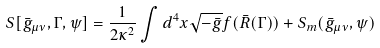Convert formula to latex. <formula><loc_0><loc_0><loc_500><loc_500>S [ \bar { g } _ { \mu \nu } , \Gamma , \psi ] = \frac { 1 } { 2 \kappa ^ { 2 } } \int d ^ { 4 } x \sqrt { - \bar { g } } f ( \bar { R } ( \Gamma ) ) + S _ { m } ( \bar { g } _ { \mu \nu } , \psi )</formula> 